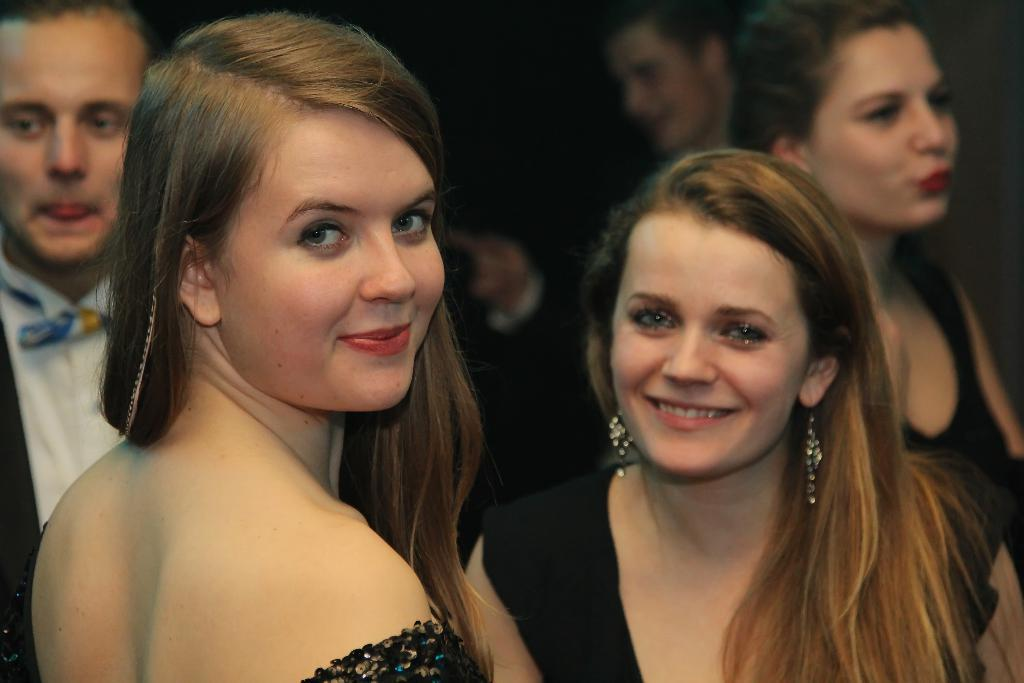How many women are in the image? There are two women in the image. What are the women doing in the image? The women are smiling and posing for the camera. Can you describe the man in the background of the image? The man in the background is wearing a black coat and a white shirt. What type of skirt is the man wearing in the image? There is no skirt mentioned or visible in the image; the man is wearing a black coat and a white shirt. 